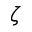Convert formula to latex. <formula><loc_0><loc_0><loc_500><loc_500>\zeta</formula> 